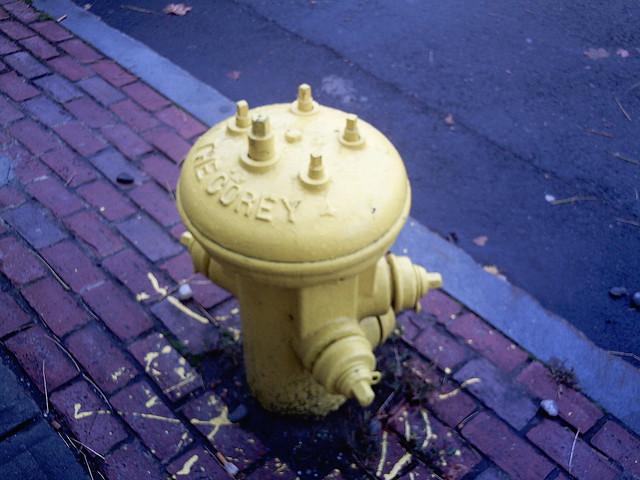How many nuts sticking out of the hydrant?
Give a very brief answer. 5. 